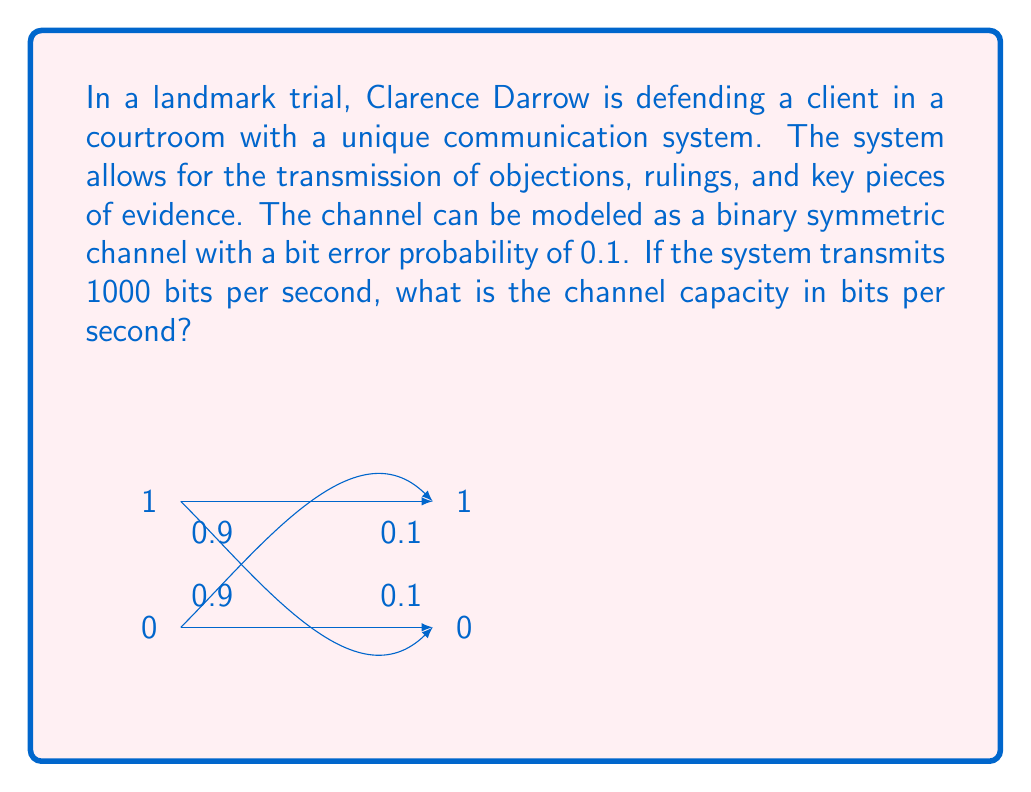Can you solve this math problem? To solve this problem, we'll use the channel capacity formula for a binary symmetric channel and then apply it to the given transmission rate. Let's break it down step-by-step:

1) The channel capacity formula for a binary symmetric channel is:

   $$C = 1 - H(p)$$

   where $C$ is the capacity in bits per channel use, and $H(p)$ is the binary entropy function.

2) The binary entropy function is defined as:

   $$H(p) = -p \log_2(p) - (1-p) \log_2(1-p)$$

3) In our case, $p = 0.1$ (the bit error probability). Let's calculate $H(0.1)$:

   $$H(0.1) = -0.1 \log_2(0.1) - 0.9 \log_2(0.9)$$

4) Using a calculator or computer:

   $$H(0.1) \approx 0.4690$$

5) Now we can calculate the capacity per channel use:

   $$C = 1 - H(0.1) \approx 1 - 0.4690 = 0.5310$$

6) This means that for each bit transmitted, we can reliably communicate 0.5310 bits of information.

7) Since the system transmits 1000 bits per second, the total channel capacity in bits per second is:

   $$\text{Total Capacity} = 1000 \times 0.5310 = 531 \text{ bits/second}$$

Thus, the channel capacity of the courtroom communication system is approximately 531 bits per second.
Answer: 531 bits/second 